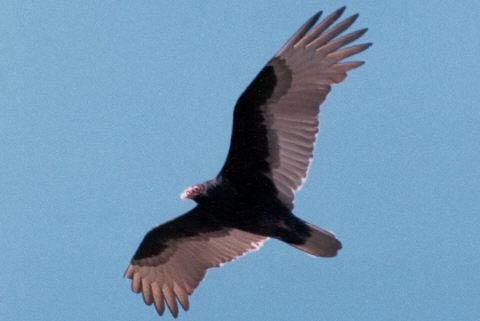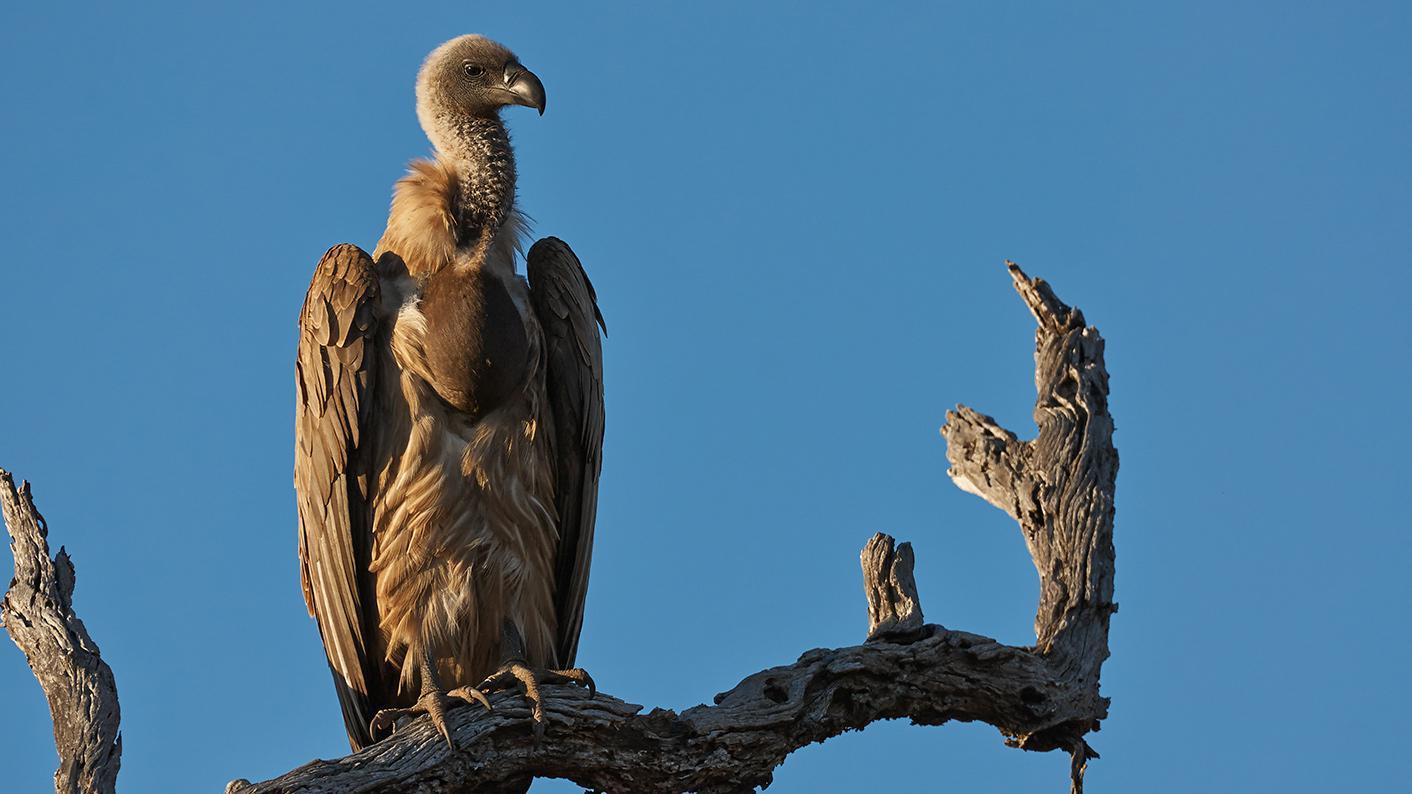The first image is the image on the left, the second image is the image on the right. For the images displayed, is the sentence "A vulture is sitting on a branch of dead wood with segments that extend up beside its body." factually correct? Answer yes or no. Yes. 